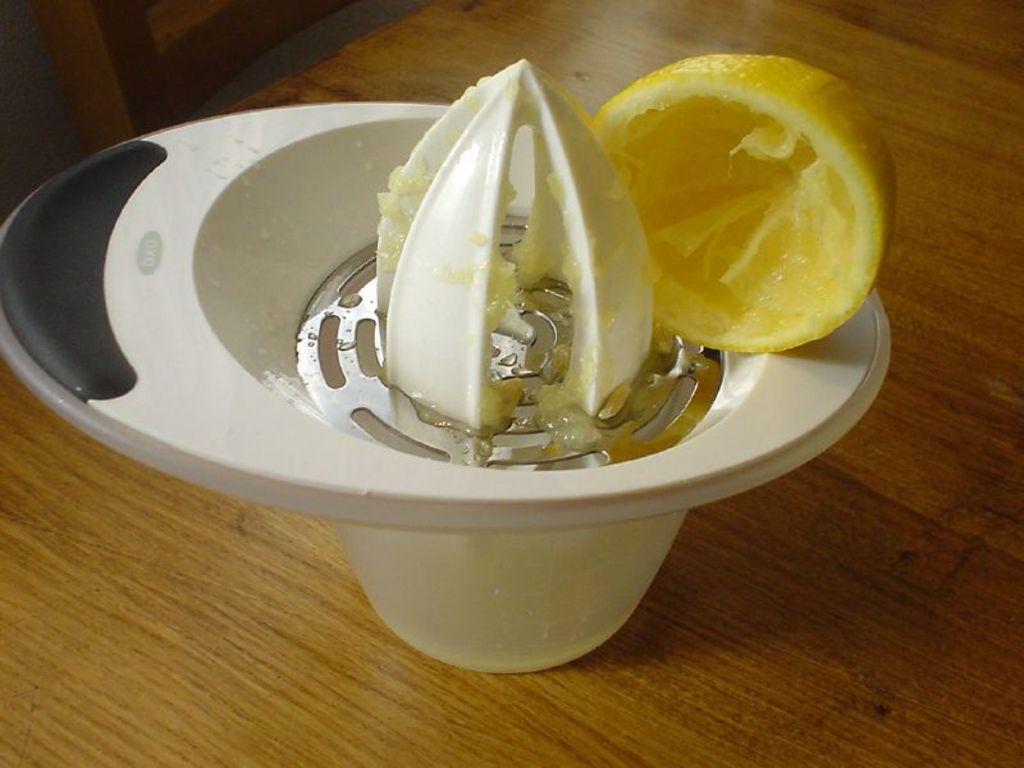Please provide a concise description of this image. In this image, I can see a juice squeezer with a lemon on it. This juice squeezer is placed on the wooden table. 